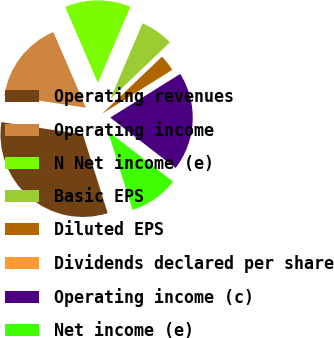<chart> <loc_0><loc_0><loc_500><loc_500><pie_chart><fcel>Operating revenues<fcel>Operating income<fcel>N Net income (e)<fcel>Basic EPS<fcel>Diluted EPS<fcel>Dividends declared per share<fcel>Operating income (c)<fcel>Net income (e)<nl><fcel>32.25%<fcel>16.13%<fcel>12.9%<fcel>6.46%<fcel>3.23%<fcel>0.01%<fcel>19.35%<fcel>9.68%<nl></chart> 